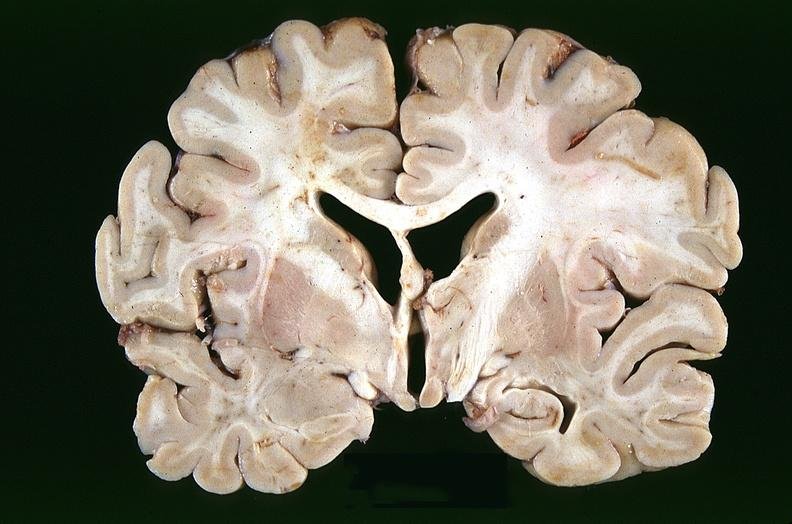does heel ulcer show brain, infarcts, hypotension?
Answer the question using a single word or phrase. No 